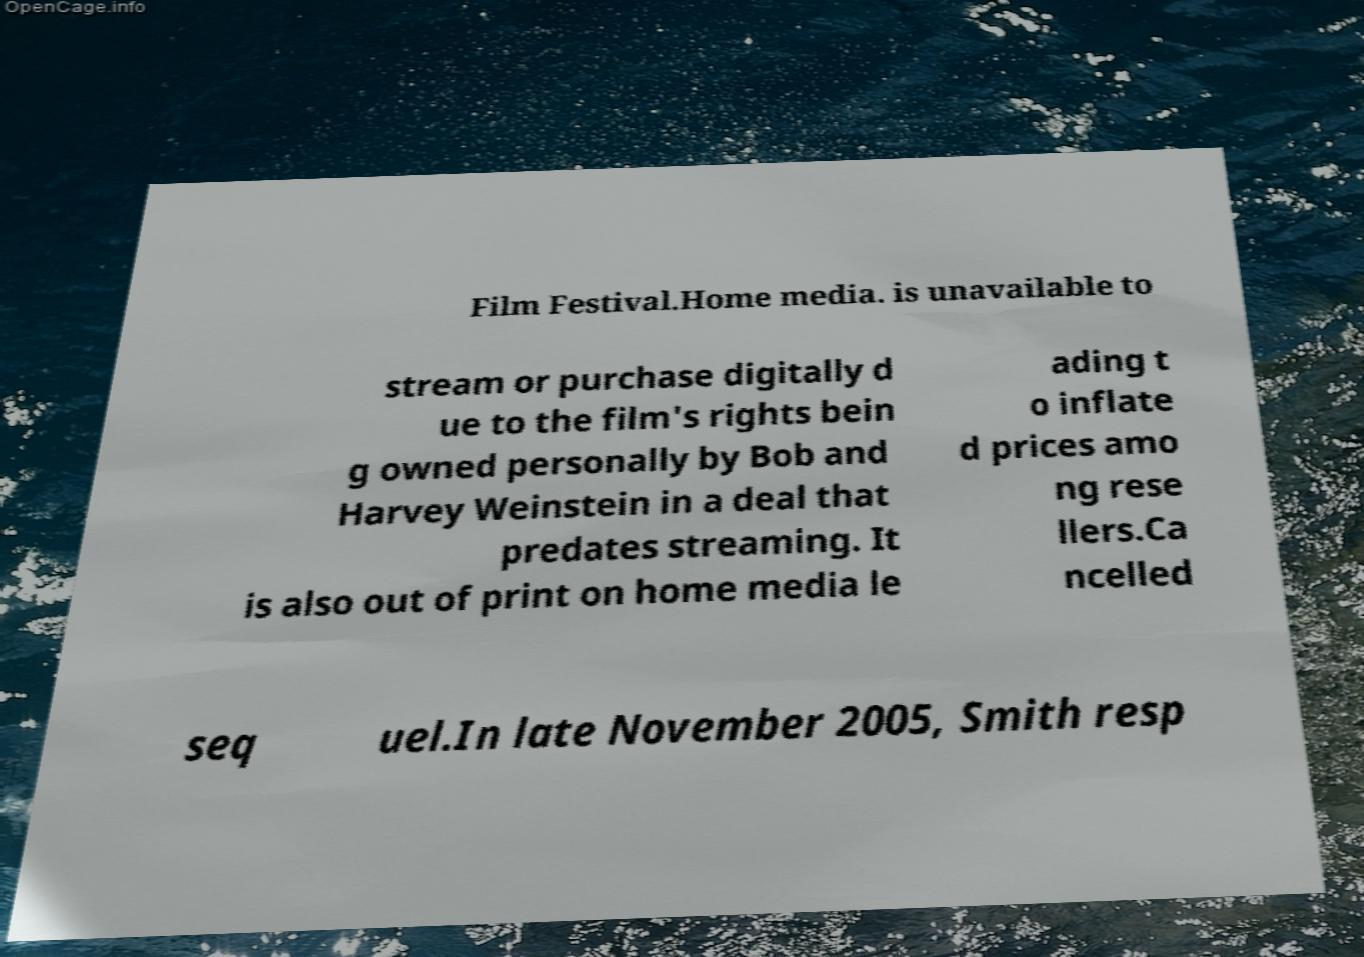Could you extract and type out the text from this image? Film Festival.Home media. is unavailable to stream or purchase digitally d ue to the film's rights bein g owned personally by Bob and Harvey Weinstein in a deal that predates streaming. It is also out of print on home media le ading t o inflate d prices amo ng rese llers.Ca ncelled seq uel.In late November 2005, Smith resp 